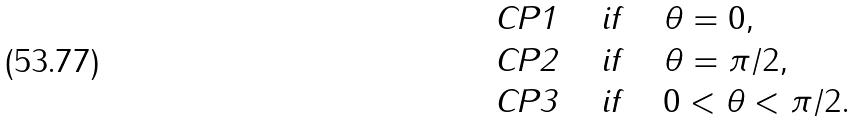Convert formula to latex. <formula><loc_0><loc_0><loc_500><loc_500>& \text {CP1} \quad \text { if } \quad \theta = 0 , \\ & \text {CP2} \quad \text { if } \quad \theta = \pi / 2 , \\ & \text {CP3} \quad \text { if } \quad 0 < \theta < \pi / 2 .</formula> 